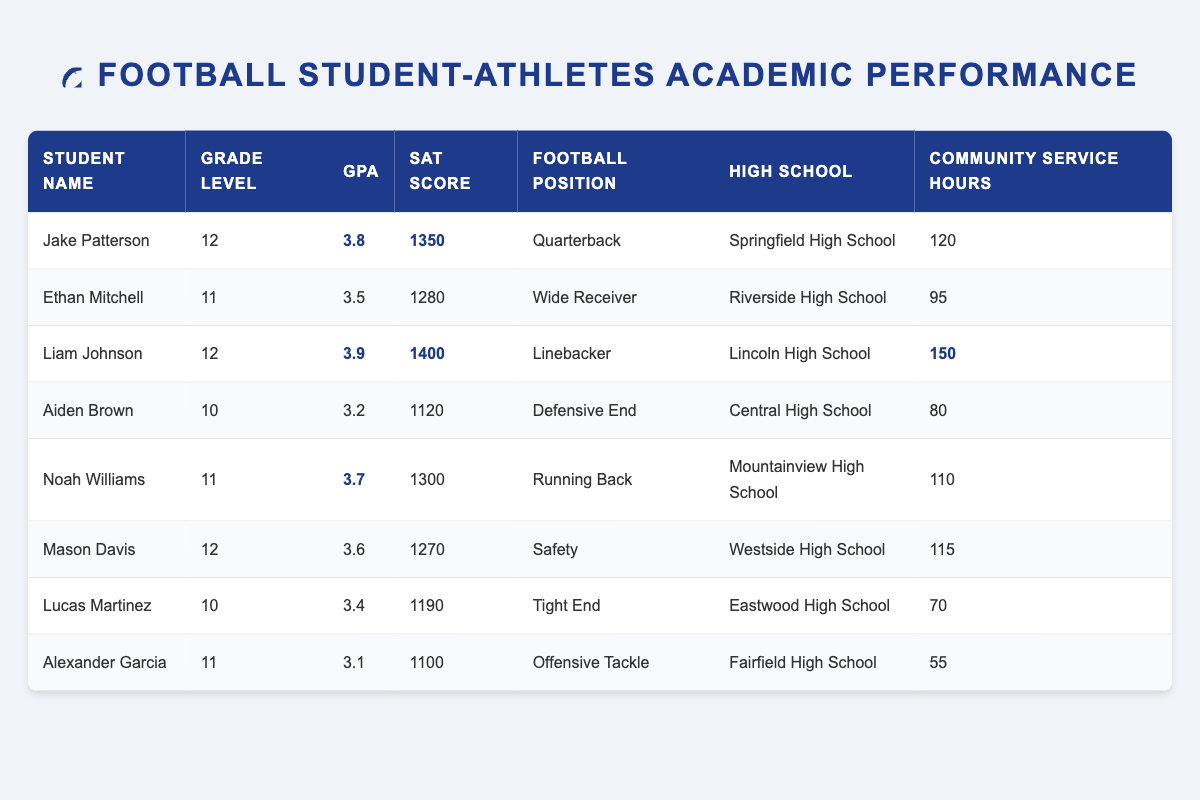What is the highest GPA among the student-athletes? The table lists the GPAs for each student-athlete, and the highest GPA is highlighted as 3.9 for Liam Johnson.
Answer: 3.9 Which student has the most community service hours? Looking at the community service hours for each student, Liam Johnson has the highest at 150 hours, which is also highlighted in the table.
Answer: 150 How many student-athletes have a GPA of 3.5 or higher? From the table, the GPAs that are 3.5 or higher are 3.8, 3.9, 3.7, and 3.6, which reflects 4 student-athletes.
Answer: 4 What is the average SAT score of the students in grade 11? First, we identify the SAT scores of students in grade 11: Ethan Mitchell (1280), Noah Williams (1300), and Alexander Garcia (1100). Their total is 1280 + 1300 + 1100 = 3680. There are 3 students, so the average is 3680 / 3 = approximately 1226.67.
Answer: 1226.67 Is there a student who has both a GPA over 3.5 and more than 100 community service hours? Yes, we check each student and find that Liam Johnson has a GPA of 3.9 and 150 community service hours, while Noah Williams has a GPA of 3.7 and 110 hours. Therefore, there are students who meet both criteria.
Answer: Yes What is the total community service hours for all students? We add the community service hours for each student: 120 + 95 + 150 + 80 + 110 + 115 + 70 + 55 = 1000 hours total.
Answer: 1000 Which football position has the highest average GPA among the listed student-athletes? We find the GPAs for each position: Quarterback (3.8), Running Back (3.7), Wide Receiver (3.5), Safety (3.6), Linebacker (3.9), Defensive End (3.2), Offensive Tackle (3.1), Tight End (3.4). The average GPA for each position (Quarterback: 3.8, Running Back: 3.7, etc.) shows that the highest average is for the Linebacker position with a GPA of 3.9.
Answer: Linebacker What is the difference in SAT scores between the highest and lowest scoring student-athletes? The highest SAT score is 1400 (Liam Johnson) and the lowest is 1100 (Alexander Garcia). The difference is 1400 - 1100 = 300.
Answer: 300 How many students play positions listed as offensive? The table includes two offensive positions: Quarterback (Jake Patterson) and Offensive Tackle (Alexander Garcia). Therefore, 2 students play offensive positions.
Answer: 2 Which student-athlete attends Westside High School? We can identify from the table that Mason Davis, a Safety, attends Westside High School.
Answer: Mason Davis 